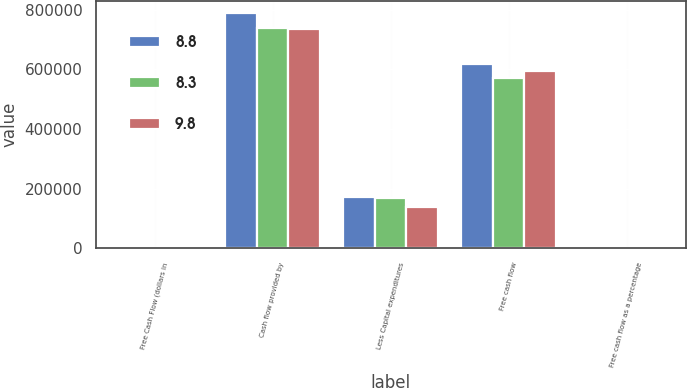Convert chart to OTSL. <chart><loc_0><loc_0><loc_500><loc_500><stacked_bar_chart><ecel><fcel>Free Cash Flow (dollars in<fcel>Cash flow provided by<fcel>Less Capital expenditures<fcel>Free cash flow<fcel>Free cash flow as a percentage<nl><fcel>8.8<fcel>2018<fcel>789193<fcel>170994<fcel>618199<fcel>8.8<nl><fcel>8.3<fcel>2017<fcel>739409<fcel>170068<fcel>569341<fcel>8.3<nl><fcel>9.8<fcel>2016<fcel>734596<fcel>139578<fcel>595018<fcel>9.8<nl></chart> 